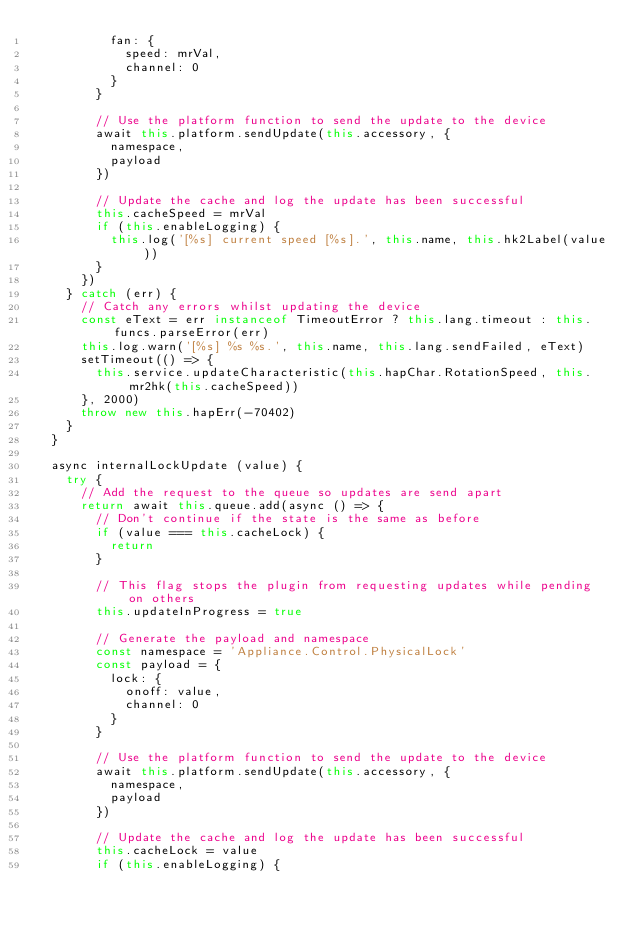Convert code to text. <code><loc_0><loc_0><loc_500><loc_500><_JavaScript_>          fan: {
            speed: mrVal,
            channel: 0
          }
        }

        // Use the platform function to send the update to the device
        await this.platform.sendUpdate(this.accessory, {
          namespace,
          payload
        })

        // Update the cache and log the update has been successful
        this.cacheSpeed = mrVal
        if (this.enableLogging) {
          this.log('[%s] current speed [%s].', this.name, this.hk2Label(value))
        }
      })
    } catch (err) {
      // Catch any errors whilst updating the device
      const eText = err instanceof TimeoutError ? this.lang.timeout : this.funcs.parseError(err)
      this.log.warn('[%s] %s %s.', this.name, this.lang.sendFailed, eText)
      setTimeout(() => {
        this.service.updateCharacteristic(this.hapChar.RotationSpeed, this.mr2hk(this.cacheSpeed))
      }, 2000)
      throw new this.hapErr(-70402)
    }
  }

  async internalLockUpdate (value) {
    try {
      // Add the request to the queue so updates are send apart
      return await this.queue.add(async () => {
        // Don't continue if the state is the same as before
        if (value === this.cacheLock) {
          return
        }

        // This flag stops the plugin from requesting updates while pending on others
        this.updateInProgress = true

        // Generate the payload and namespace
        const namespace = 'Appliance.Control.PhysicalLock'
        const payload = {
          lock: {
            onoff: value,
            channel: 0
          }
        }

        // Use the platform function to send the update to the device
        await this.platform.sendUpdate(this.accessory, {
          namespace,
          payload
        })

        // Update the cache and log the update has been successful
        this.cacheLock = value
        if (this.enableLogging) {</code> 